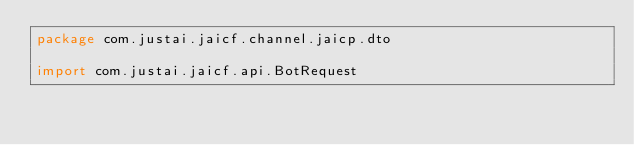<code> <loc_0><loc_0><loc_500><loc_500><_Kotlin_>package com.justai.jaicf.channel.jaicp.dto

import com.justai.jaicf.api.BotRequest</code> 